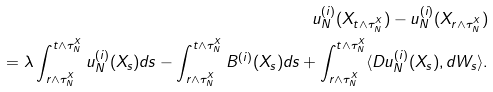<formula> <loc_0><loc_0><loc_500><loc_500>u ^ { ( i ) } _ { N } ( X _ { t \wedge \tau _ { N } ^ { X } } ) - u ^ { ( i ) } _ { N } ( X _ { r \wedge \tau _ { N } ^ { X } } ) \\ = \lambda \int _ { r \wedge \tau _ { N } ^ { X } } ^ { t \wedge \tau _ { N } ^ { X } } u ^ { ( i ) } _ { N } ( X _ { s } ) d s - \int _ { r \wedge \tau _ { N } ^ { X } } ^ { t \wedge \tau _ { N } ^ { X } } B ^ { ( i ) } ( X _ { s } ) d s + \int _ { r \wedge \tau _ { N } ^ { X } } ^ { t \wedge \tau _ { N } ^ { X } } \langle D u ^ { ( i ) } _ { N } ( X _ { s } ) , d W _ { s } \rangle .</formula> 